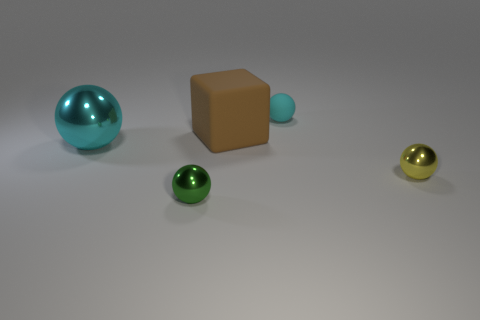Subtract 1 spheres. How many spheres are left? 3 Subtract all yellow blocks. Subtract all green cylinders. How many blocks are left? 1 Add 3 small cyan rubber balls. How many objects exist? 8 Subtract all spheres. How many objects are left? 1 Subtract all large brown shiny objects. Subtract all brown things. How many objects are left? 4 Add 2 big metallic objects. How many big metallic objects are left? 3 Add 5 large gray things. How many large gray things exist? 5 Subtract 0 yellow cylinders. How many objects are left? 5 